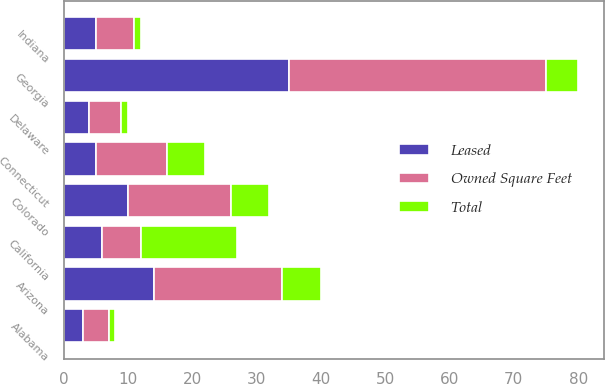Convert chart to OTSL. <chart><loc_0><loc_0><loc_500><loc_500><stacked_bar_chart><ecel><fcel>Alabama<fcel>Arizona<fcel>California<fcel>Colorado<fcel>Connecticut<fcel>Delaware<fcel>Georgia<fcel>Indiana<nl><fcel>Leased<fcel>3<fcel>14<fcel>6<fcel>10<fcel>5<fcel>4<fcel>35<fcel>5<nl><fcel>Total<fcel>1<fcel>6<fcel>15<fcel>6<fcel>6<fcel>1<fcel>5<fcel>1<nl><fcel>Owned Square Feet<fcel>4<fcel>20<fcel>6<fcel>16<fcel>11<fcel>5<fcel>40<fcel>6<nl></chart> 